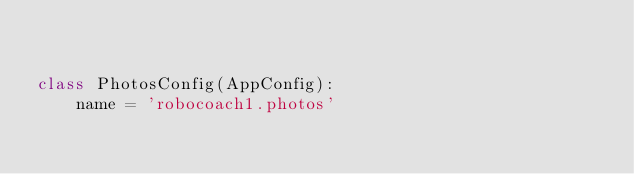<code> <loc_0><loc_0><loc_500><loc_500><_Python_>

class PhotosConfig(AppConfig):
    name = 'robocoach1.photos'
</code> 